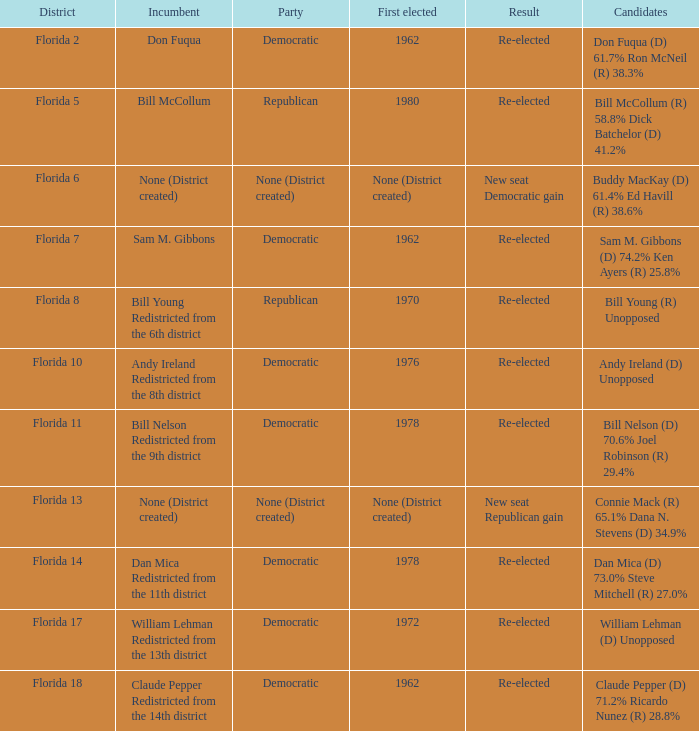What's the first elected with district being florida 7 1962.0. 